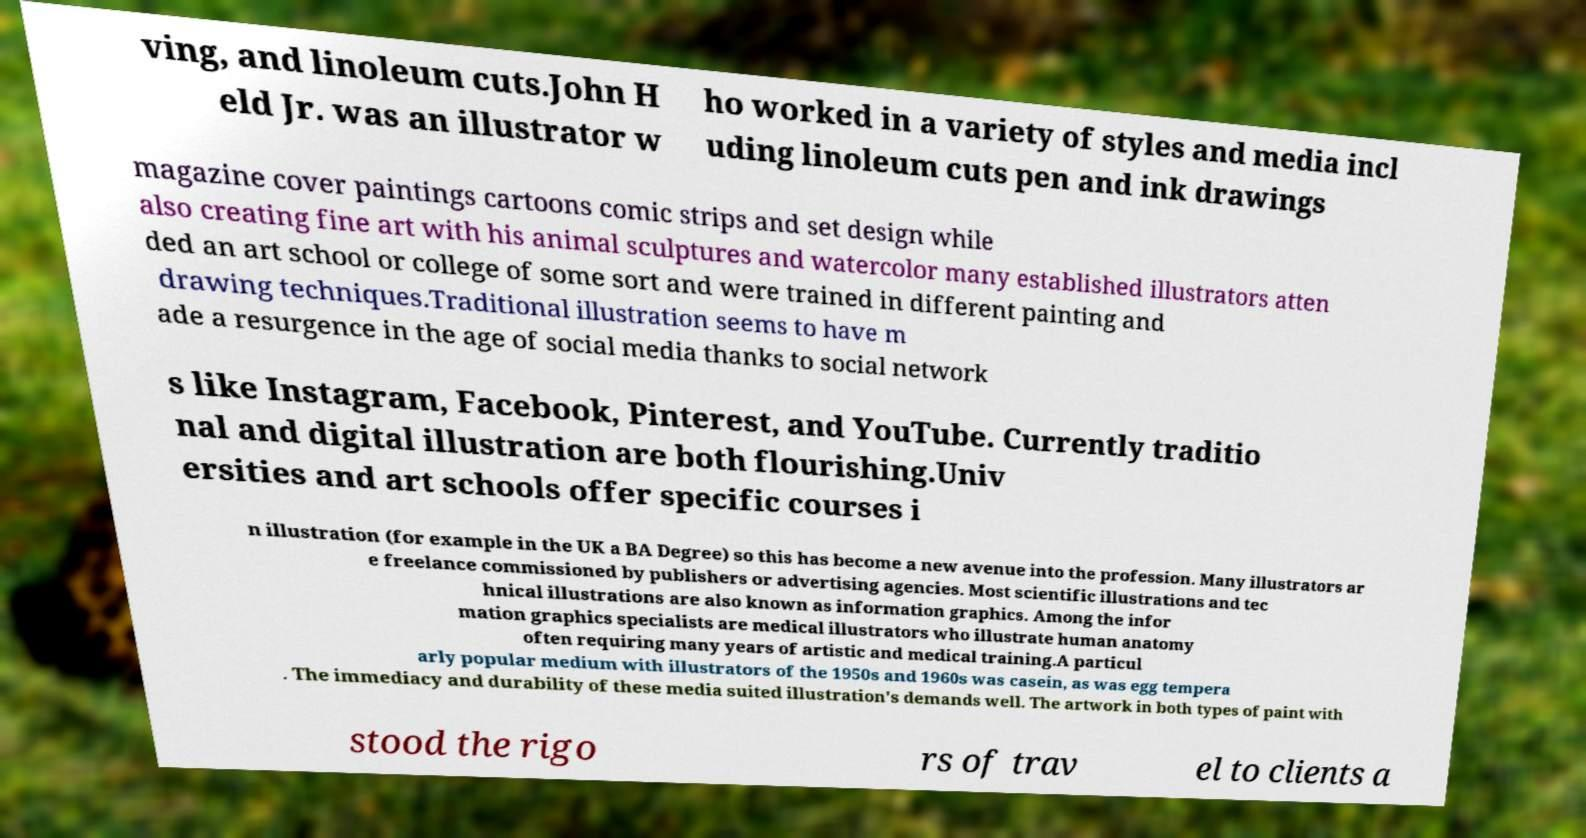Please identify and transcribe the text found in this image. ving, and linoleum cuts.John H eld Jr. was an illustrator w ho worked in a variety of styles and media incl uding linoleum cuts pen and ink drawings magazine cover paintings cartoons comic strips and set design while also creating fine art with his animal sculptures and watercolor many established illustrators atten ded an art school or college of some sort and were trained in different painting and drawing techniques.Traditional illustration seems to have m ade a resurgence in the age of social media thanks to social network s like Instagram, Facebook, Pinterest, and YouTube. Currently traditio nal and digital illustration are both flourishing.Univ ersities and art schools offer specific courses i n illustration (for example in the UK a BA Degree) so this has become a new avenue into the profession. Many illustrators ar e freelance commissioned by publishers or advertising agencies. Most scientific illustrations and tec hnical illustrations are also known as information graphics. Among the infor mation graphics specialists are medical illustrators who illustrate human anatomy often requiring many years of artistic and medical training.A particul arly popular medium with illustrators of the 1950s and 1960s was casein, as was egg tempera . The immediacy and durability of these media suited illustration's demands well. The artwork in both types of paint with stood the rigo rs of trav el to clients a 